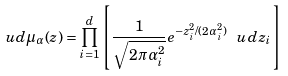<formula> <loc_0><loc_0><loc_500><loc_500>\ u d \mu _ { \alpha } ( z ) = \prod _ { i = 1 } ^ { d } \left [ \frac { 1 } { \sqrt { 2 \pi \alpha _ { i } ^ { 2 } } } e ^ { - z _ { i } ^ { 2 } / ( 2 \alpha _ { i } ^ { 2 } ) } \ u d z _ { i } \right ]</formula> 